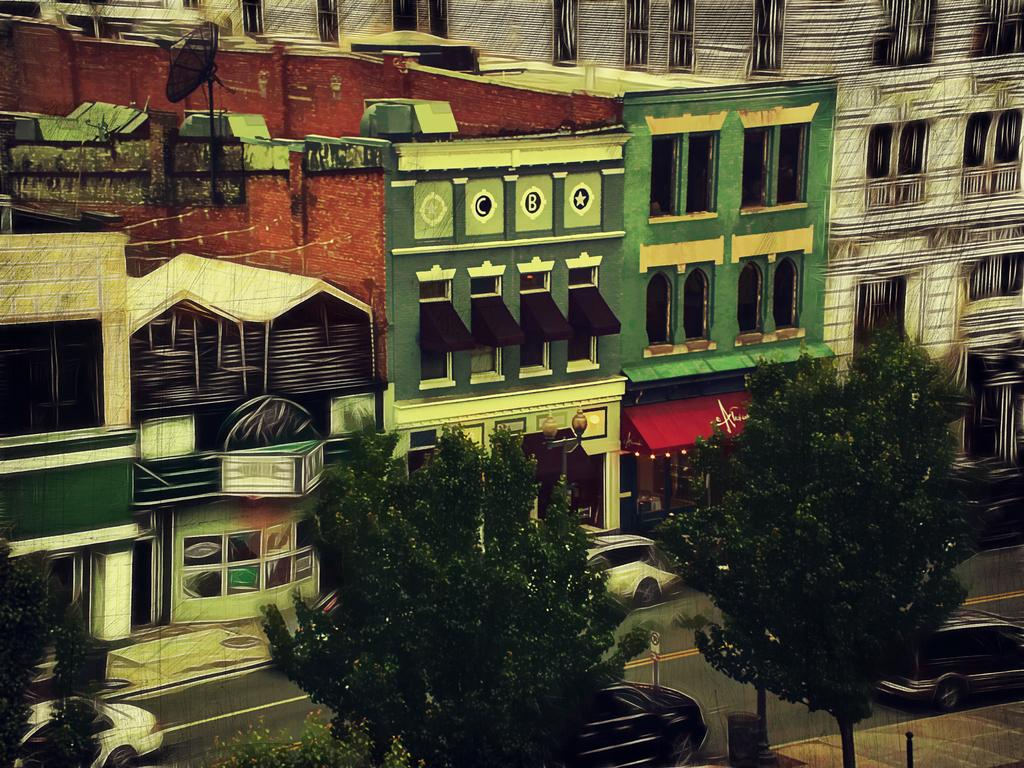What type of artwork is depicted in the image? The image is a painting. What structures can be seen in the painting? There are buildings in the painting. What type of vegetation is present in the painting? There are trees in the painting. What mode of transportation can be seen in the painting? There are cars in the painting. What type of kettle is whistling in the painting? There is no kettle present in the painting. How does the painting stop moving in the image? The painting does not move; it is a static image. 